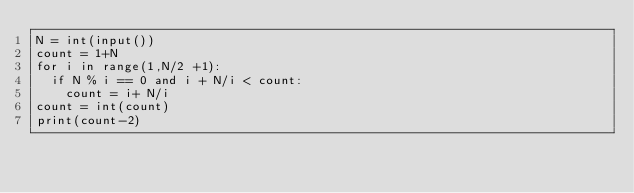<code> <loc_0><loc_0><loc_500><loc_500><_Python_>N = int(input())
count = 1+N
for i in range(1,N/2 +1):
  if N % i == 0 and i + N/i < count:
    count = i+ N/i
count = int(count)
print(count-2)
</code> 